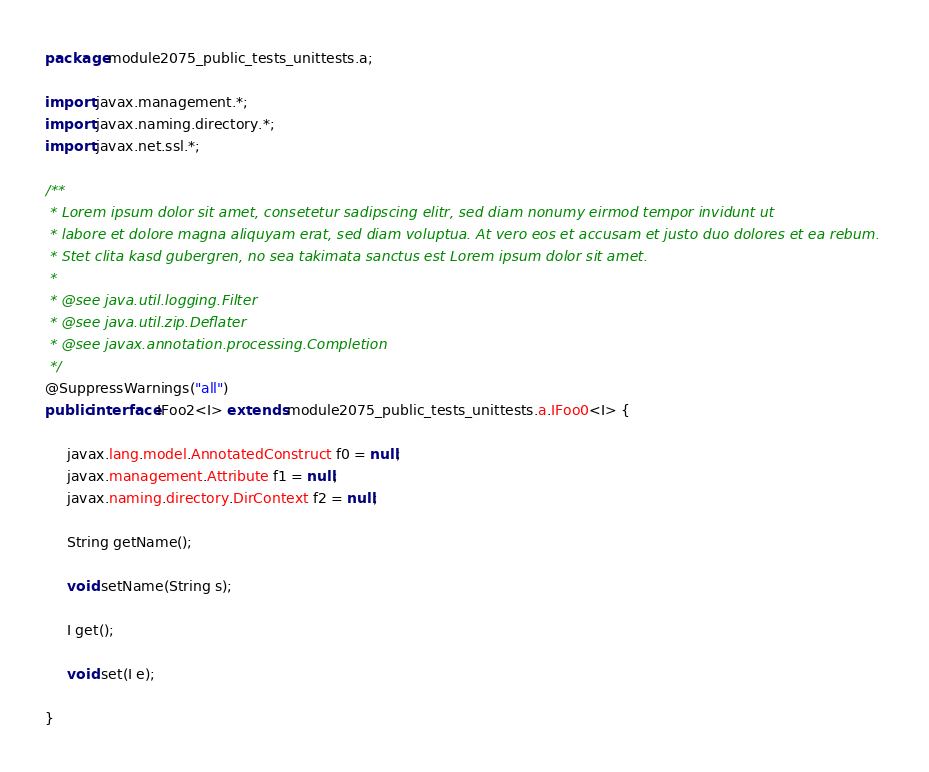Convert code to text. <code><loc_0><loc_0><loc_500><loc_500><_Java_>package module2075_public_tests_unittests.a;

import javax.management.*;
import javax.naming.directory.*;
import javax.net.ssl.*;

/**
 * Lorem ipsum dolor sit amet, consetetur sadipscing elitr, sed diam nonumy eirmod tempor invidunt ut 
 * labore et dolore magna aliquyam erat, sed diam voluptua. At vero eos et accusam et justo duo dolores et ea rebum. 
 * Stet clita kasd gubergren, no sea takimata sanctus est Lorem ipsum dolor sit amet. 
 *
 * @see java.util.logging.Filter
 * @see java.util.zip.Deflater
 * @see javax.annotation.processing.Completion
 */
@SuppressWarnings("all")
public interface IFoo2<I> extends module2075_public_tests_unittests.a.IFoo0<I> {

	 javax.lang.model.AnnotatedConstruct f0 = null;
	 javax.management.Attribute f1 = null;
	 javax.naming.directory.DirContext f2 = null;

	 String getName();

	 void setName(String s);

	 I get();

	 void set(I e);

}
</code> 